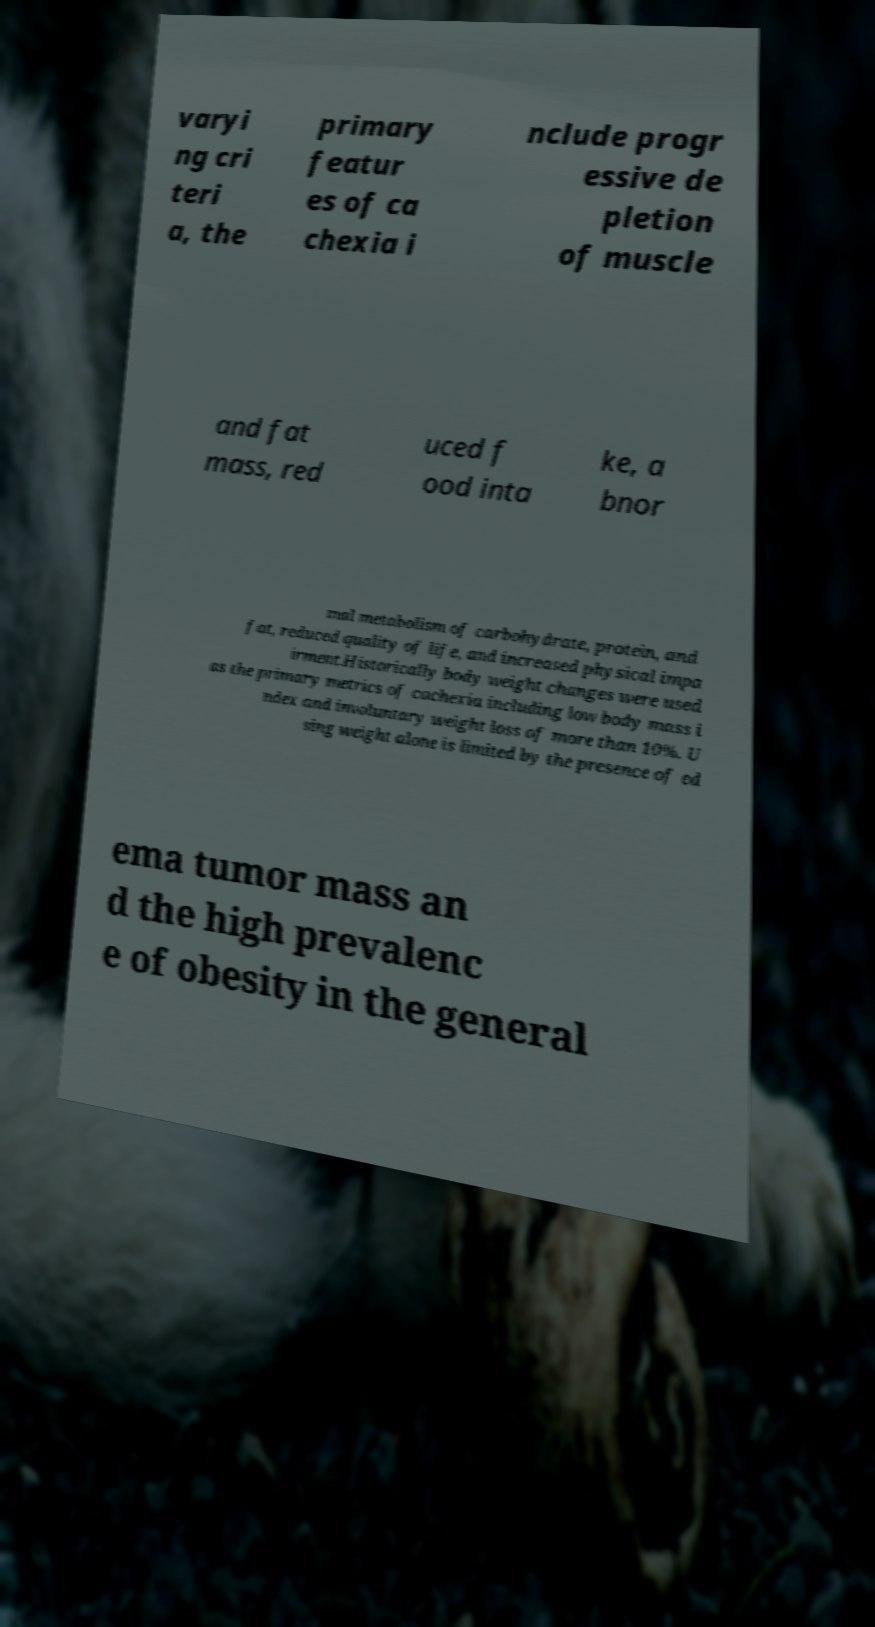Could you extract and type out the text from this image? varyi ng cri teri a, the primary featur es of ca chexia i nclude progr essive de pletion of muscle and fat mass, red uced f ood inta ke, a bnor mal metabolism of carbohydrate, protein, and fat, reduced quality of life, and increased physical impa irment.Historically body weight changes were used as the primary metrics of cachexia including low body mass i ndex and involuntary weight loss of more than 10%. U sing weight alone is limited by the presence of ed ema tumor mass an d the high prevalenc e of obesity in the general 